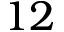Convert formula to latex. <formula><loc_0><loc_0><loc_500><loc_500>1 2</formula> 